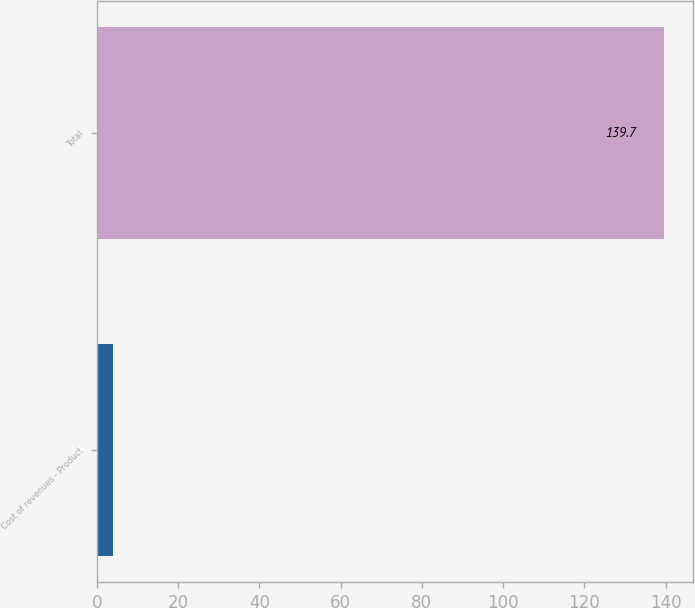Convert chart to OTSL. <chart><loc_0><loc_0><loc_500><loc_500><bar_chart><fcel>Cost of revenues - Product<fcel>Total<nl><fcel>3.9<fcel>139.7<nl></chart> 